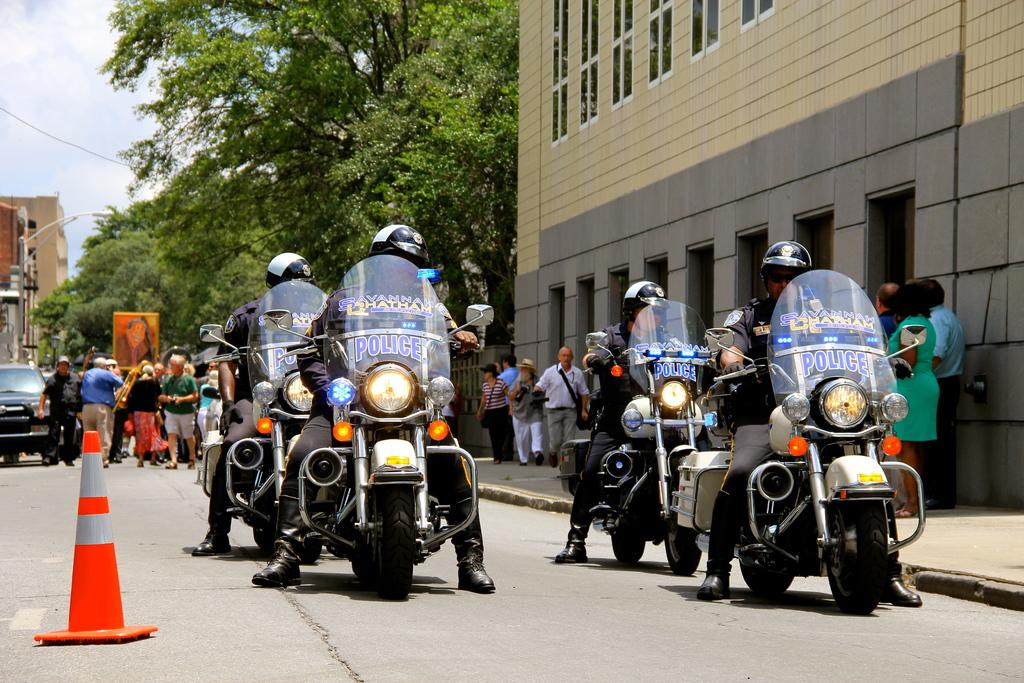How many police officers are in the image? There are four police officers in the image. What are the police officers doing in the image? The police officers are riding bikes in the image. Where are the bikes located in the image? The bikes are on the road in the image. What can be seen on the right side of the image? There is a building on the right side of the image. What type of vegetation is in the middle of the image? There are trees in the middle of the image. What type of toys are the chickens playing with in the image? There are no chickens or toys present in the image. 